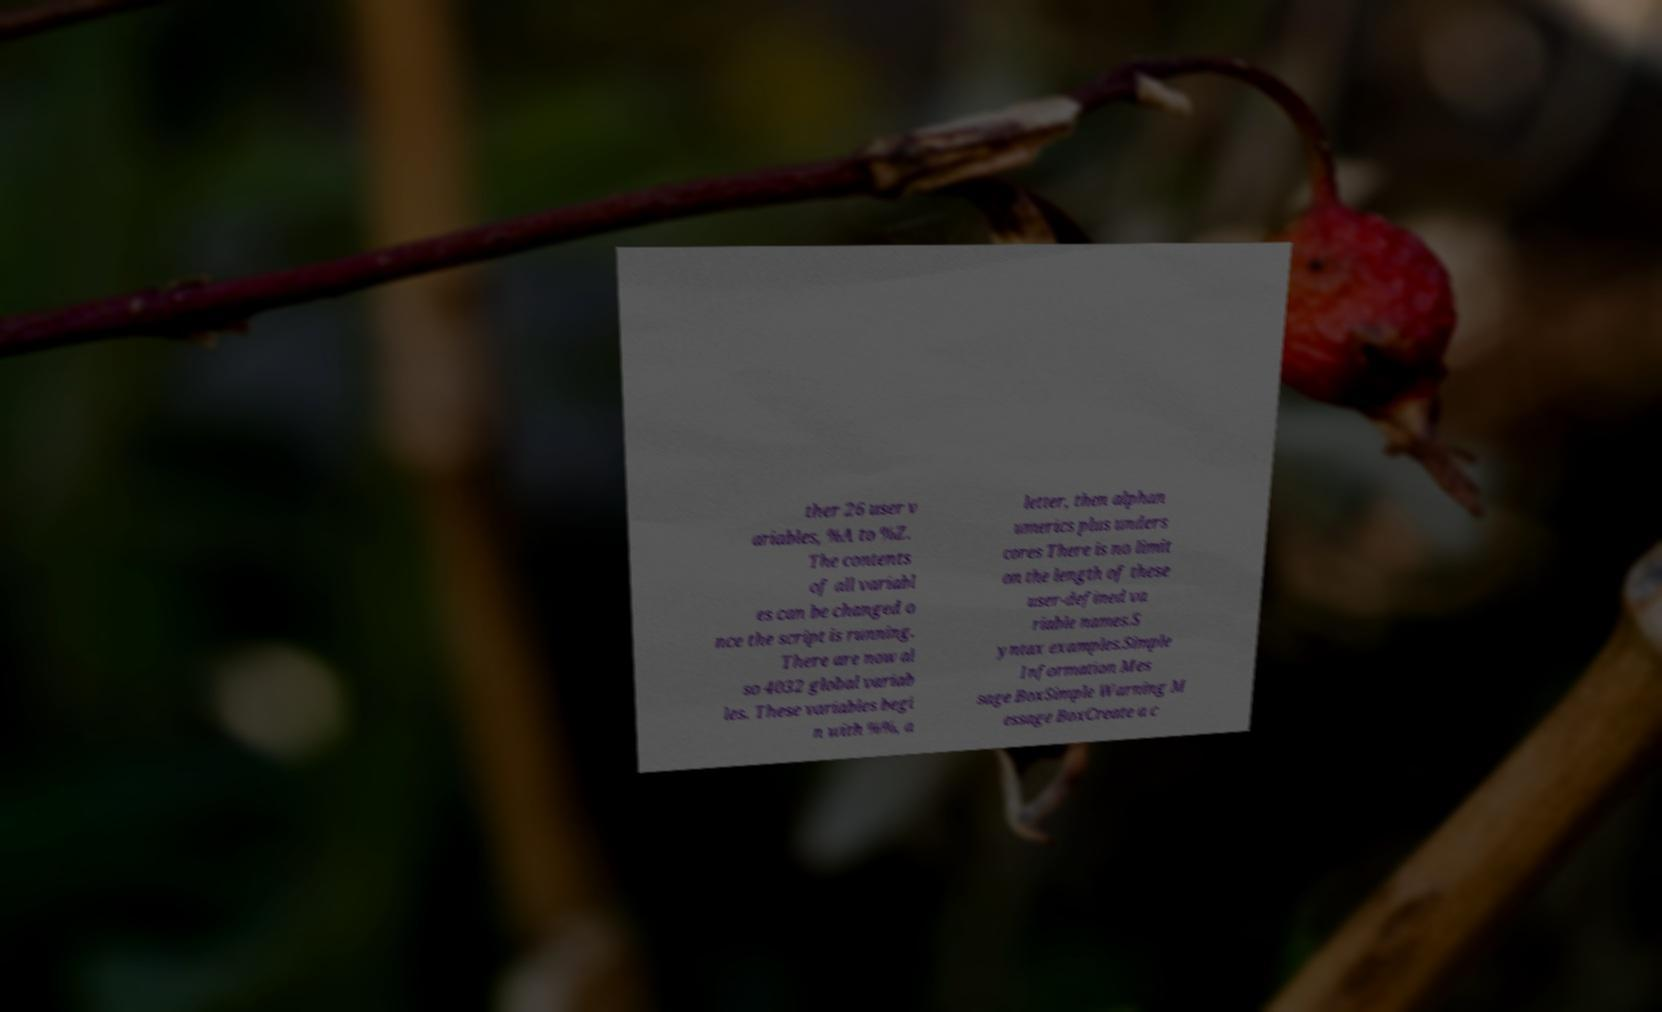Can you accurately transcribe the text from the provided image for me? ther 26 user v ariables, %A to %Z. The contents of all variabl es can be changed o nce the script is running. There are now al so 4032 global variab les. These variables begi n with %%, a letter, then alphan umerics plus unders cores There is no limit on the length of these user-defined va riable names.S yntax examples.Simple Information Mes sage BoxSimple Warning M essage BoxCreate a c 